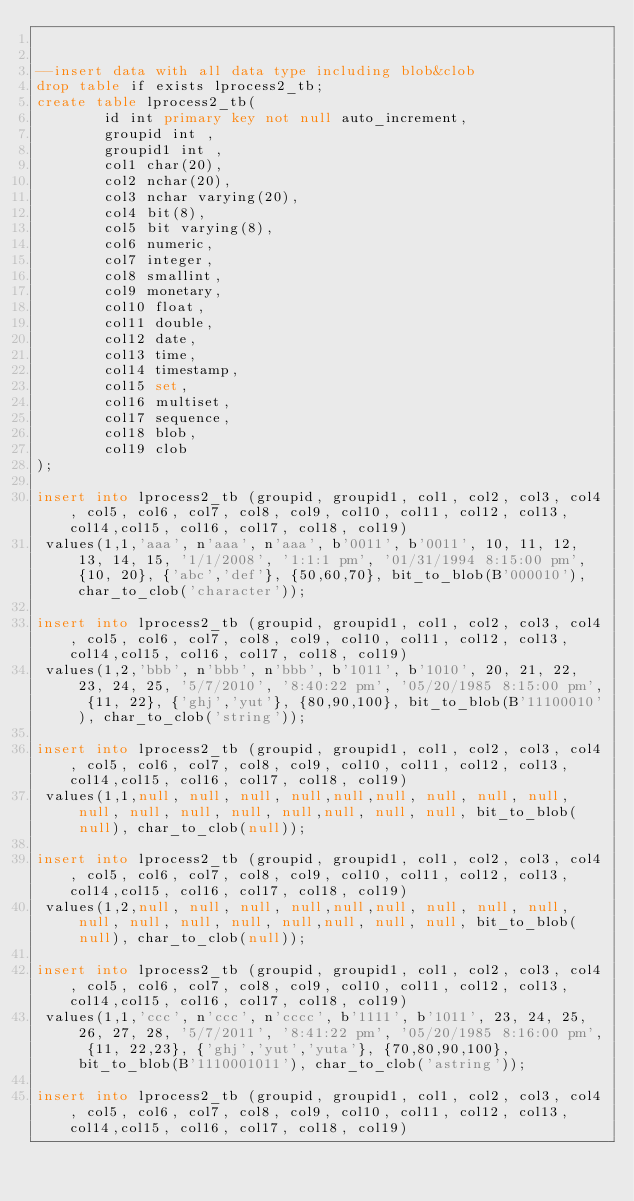Convert code to text. <code><loc_0><loc_0><loc_500><loc_500><_SQL_>

--insert data with all data type including blob&clob
drop table if exists lprocess2_tb;
create table lprocess2_tb(
        id int primary key not null auto_increment,
        groupid int ,
        groupid1 int ,
        col1 char(20),
        col2 nchar(20),
        col3 nchar varying(20),
        col4 bit(8),
        col5 bit varying(8),
        col6 numeric,
        col7 integer,
        col8 smallint,
        col9 monetary,
        col10 float,
        col11 double,
        col12 date,
        col13 time,
        col14 timestamp,
        col15 set,
        col16 multiset,
        col17 sequence,
        col18 blob,
        col19 clob
);

insert into lprocess2_tb (groupid, groupid1, col1, col2, col3, col4, col5, col6, col7, col8, col9, col10, col11, col12, col13, col14,col15, col16, col17, col18, col19)
 values(1,1,'aaa', n'aaa', n'aaa', b'0011', b'0011', 10, 11, 12, 13, 14, 15, '1/1/2008', '1:1:1 pm', '01/31/1994 8:15:00 pm', {10, 20}, {'abc','def'}, {50,60,70}, bit_to_blob(B'000010'), char_to_clob('character'));
 
insert into lprocess2_tb (groupid, groupid1, col1, col2, col3, col4, col5, col6, col7, col8, col9, col10, col11, col12, col13, col14,col15, col16, col17, col18, col19)
 values(1,2,'bbb', n'bbb', n'bbb', b'1011', b'1010', 20, 21, 22, 23, 24, 25, '5/7/2010', '8:40:22 pm', '05/20/1985 8:15:00 pm', {11, 22}, {'ghj','yut'}, {80,90,100}, bit_to_blob(B'11100010'), char_to_clob('string'));

insert into lprocess2_tb (groupid, groupid1, col1, col2, col3, col4, col5, col6, col7, col8, col9, col10, col11, col12, col13, col14,col15, col16, col17, col18, col19)
 values(1,1,null, null, null, null,null,null, null, null, null, null, null, null, null, null,null, null, null, bit_to_blob(null), char_to_clob(null));

insert into lprocess2_tb (groupid, groupid1, col1, col2, col3, col4, col5, col6, col7, col8, col9, col10, col11, col12, col13, col14,col15, col16, col17, col18, col19)
 values(1,2,null, null, null, null,null,null, null, null, null, null, null, null, null, null,null, null, null, bit_to_blob(null), char_to_clob(null));

insert into lprocess2_tb (groupid, groupid1, col1, col2, col3, col4, col5, col6, col7, col8, col9, col10, col11, col12, col13, col14,col15, col16, col17, col18, col19)
 values(1,1,'ccc', n'ccc', n'cccc', b'1111', b'1011', 23, 24, 25, 26, 27, 28, '5/7/2011', '8:41:22 pm', '05/20/1985 8:16:00 pm', {11, 22,23}, {'ghj','yut','yuta'}, {70,80,90,100}, bit_to_blob(B'1110001011'), char_to_clob('astring'));

insert into lprocess2_tb (groupid, groupid1, col1, col2, col3, col4, col5, col6, col7, col8, col9, col10, col11, col12, col13, col14,col15, col16, col17, col18, col19)</code> 